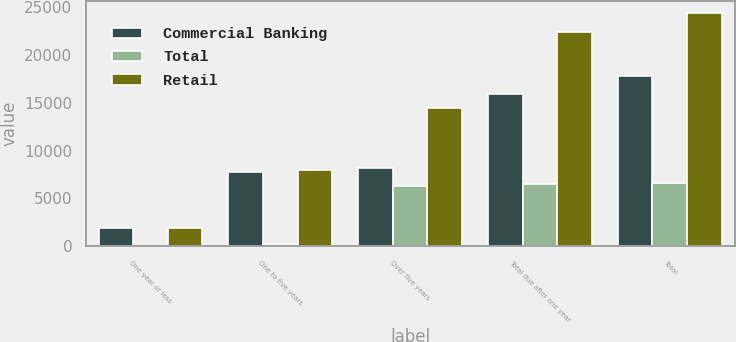<chart> <loc_0><loc_0><loc_500><loc_500><stacked_bar_chart><ecel><fcel>One year or less<fcel>One to five years<fcel>Over five years<fcel>Total due after one year<fcel>Total<nl><fcel>Commercial Banking<fcel>1876.7<fcel>7780.3<fcel>8159.8<fcel>15940.1<fcel>17816.8<nl><fcel>Total<fcel>69.5<fcel>209.7<fcel>6294.3<fcel>6504<fcel>6573.5<nl><fcel>Retail<fcel>1946.2<fcel>7990<fcel>14454.1<fcel>22444.1<fcel>24390.3<nl></chart> 